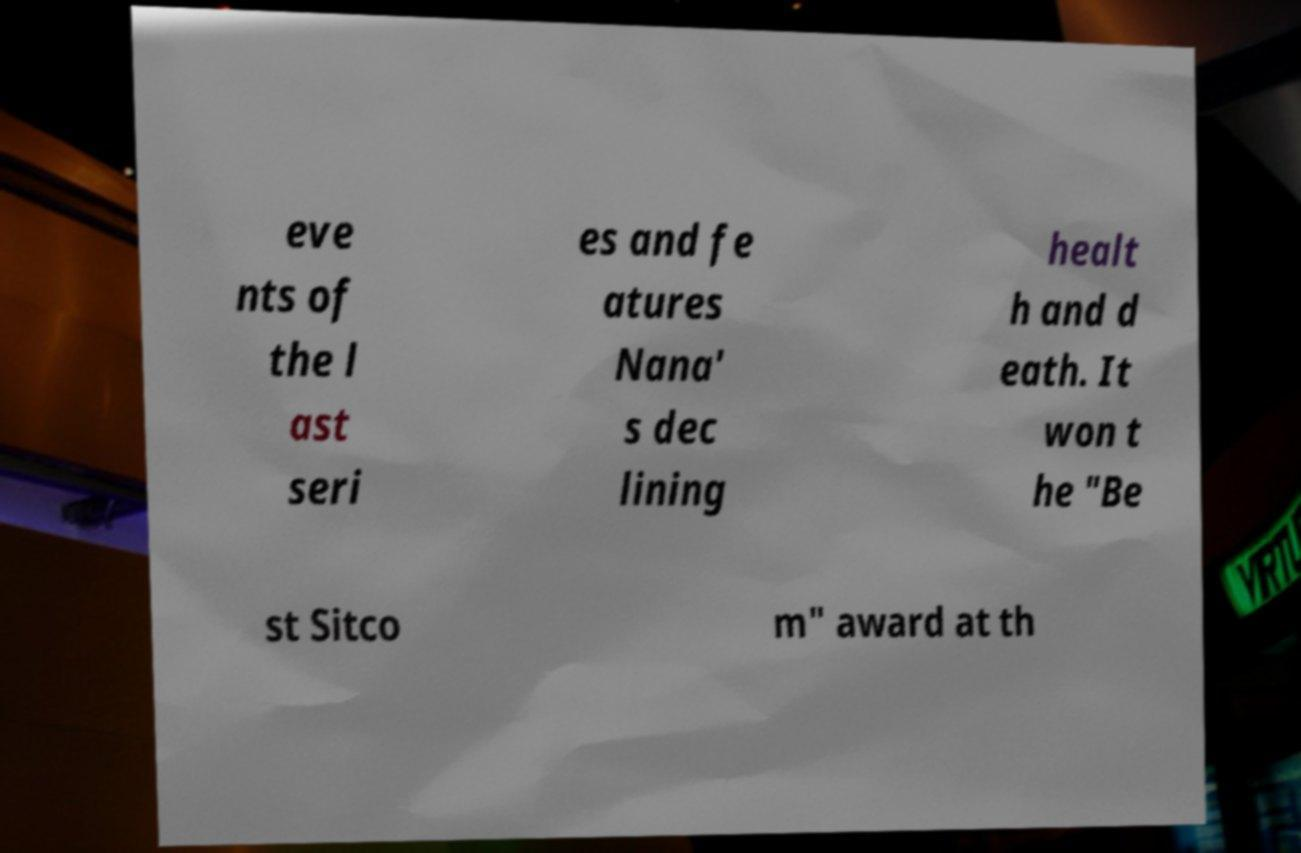Could you extract and type out the text from this image? eve nts of the l ast seri es and fe atures Nana' s dec lining healt h and d eath. It won t he "Be st Sitco m" award at th 